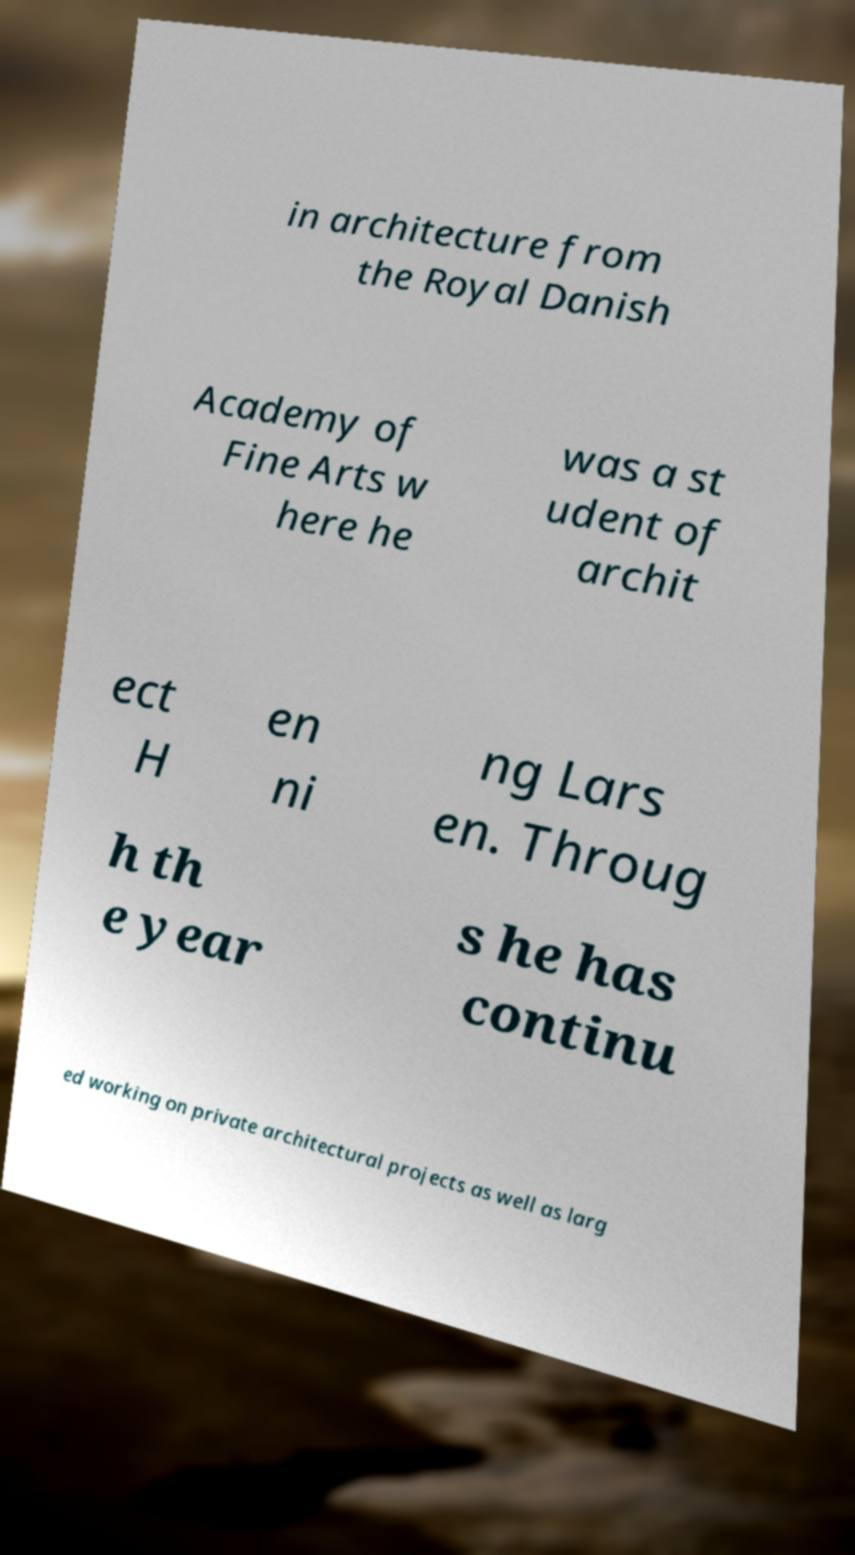What messages or text are displayed in this image? I need them in a readable, typed format. in architecture from the Royal Danish Academy of Fine Arts w here he was a st udent of archit ect H en ni ng Lars en. Throug h th e year s he has continu ed working on private architectural projects as well as larg 